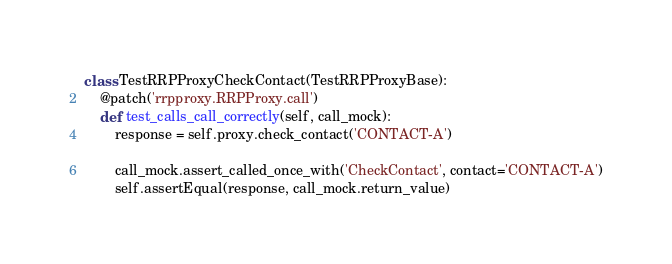<code> <loc_0><loc_0><loc_500><loc_500><_Python_>class TestRRPProxyCheckContact(TestRRPProxyBase):
    @patch('rrpproxy.RRPProxy.call')
    def test_calls_call_correctly(self, call_mock):
        response = self.proxy.check_contact('CONTACT-A')

        call_mock.assert_called_once_with('CheckContact', contact='CONTACT-A')
        self.assertEqual(response, call_mock.return_value)
</code> 